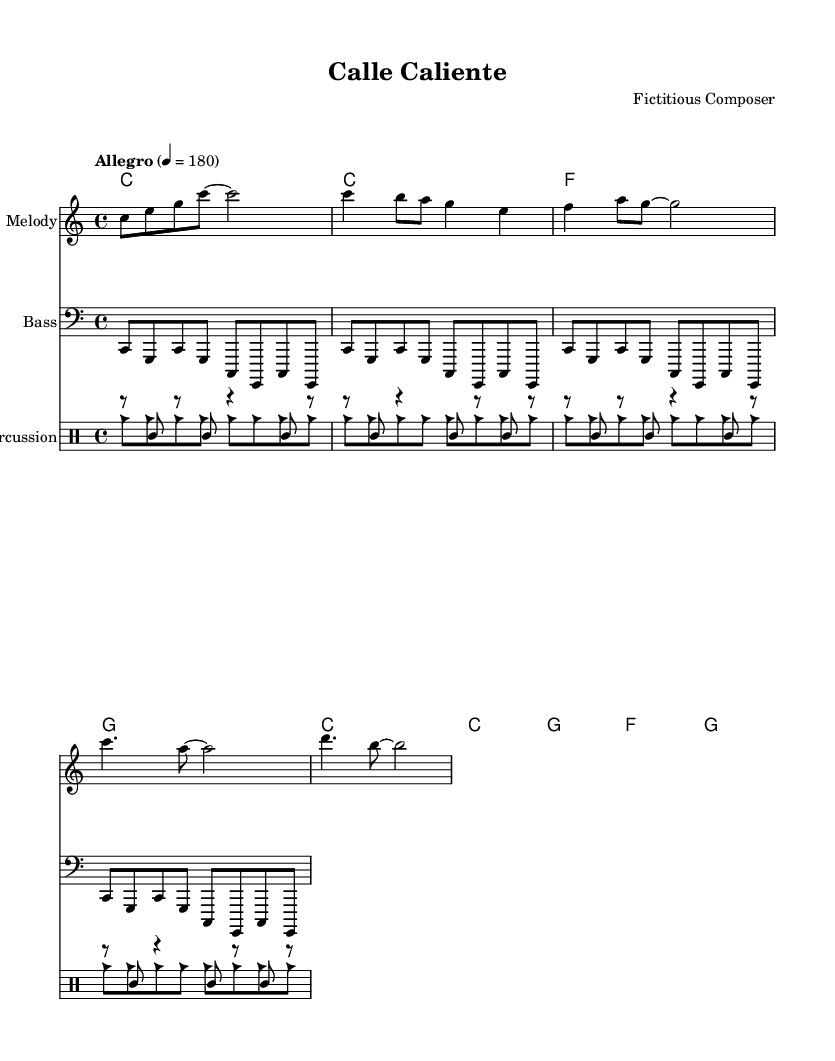What is the key signature of this music? The key signature indicated in the music is C major, represented by no sharps or flats. This can be seen at the beginning of the staff where the key is defined.
Answer: C major What is the time signature of this piece? The time signature is 4/4, which means there are four beats per measure and a quarter note gets one beat. This is visible at the beginning of the score, right next to the key signature.
Answer: 4/4 What is the tempo marking for this composition? The tempo marking is indicated as "Allegro" with a tempo of 180 beats per minute, signaling a fast and lively pace. This information appears above the staff at the beginning of the piece.
Answer: Allegro, 180 How many measures are there in the verse section? The verse section consists of 8 measures that can be counted by looking at the repeated rhythmic and melodic patterns in the music, separated by bar lines.
Answer: 8 What instrument is playing the melody in this score? The melody is written on the staff labeled as "Melody," which indicates this part is intended for a melody instrument such as a flute or violin. The staff shows the notes being played.
Answer: Melody What type of rhythm is prominent in the percussion section? The percussion section prominently features a clave rhythm, which is indicated by the specific pattern repeated throughout the beats. The notation shows repeated rhythmic sequences associated with Latin music.
Answer: Clave What are the main themes celebrated in this piece? The lyrics express themes of urban life and vibrancy, focusing on the lively atmosphere of the streets, as reflected in the text and generally in the genre of salsa. The specific words hint at a celebration of city life.
Answer: Urban life 